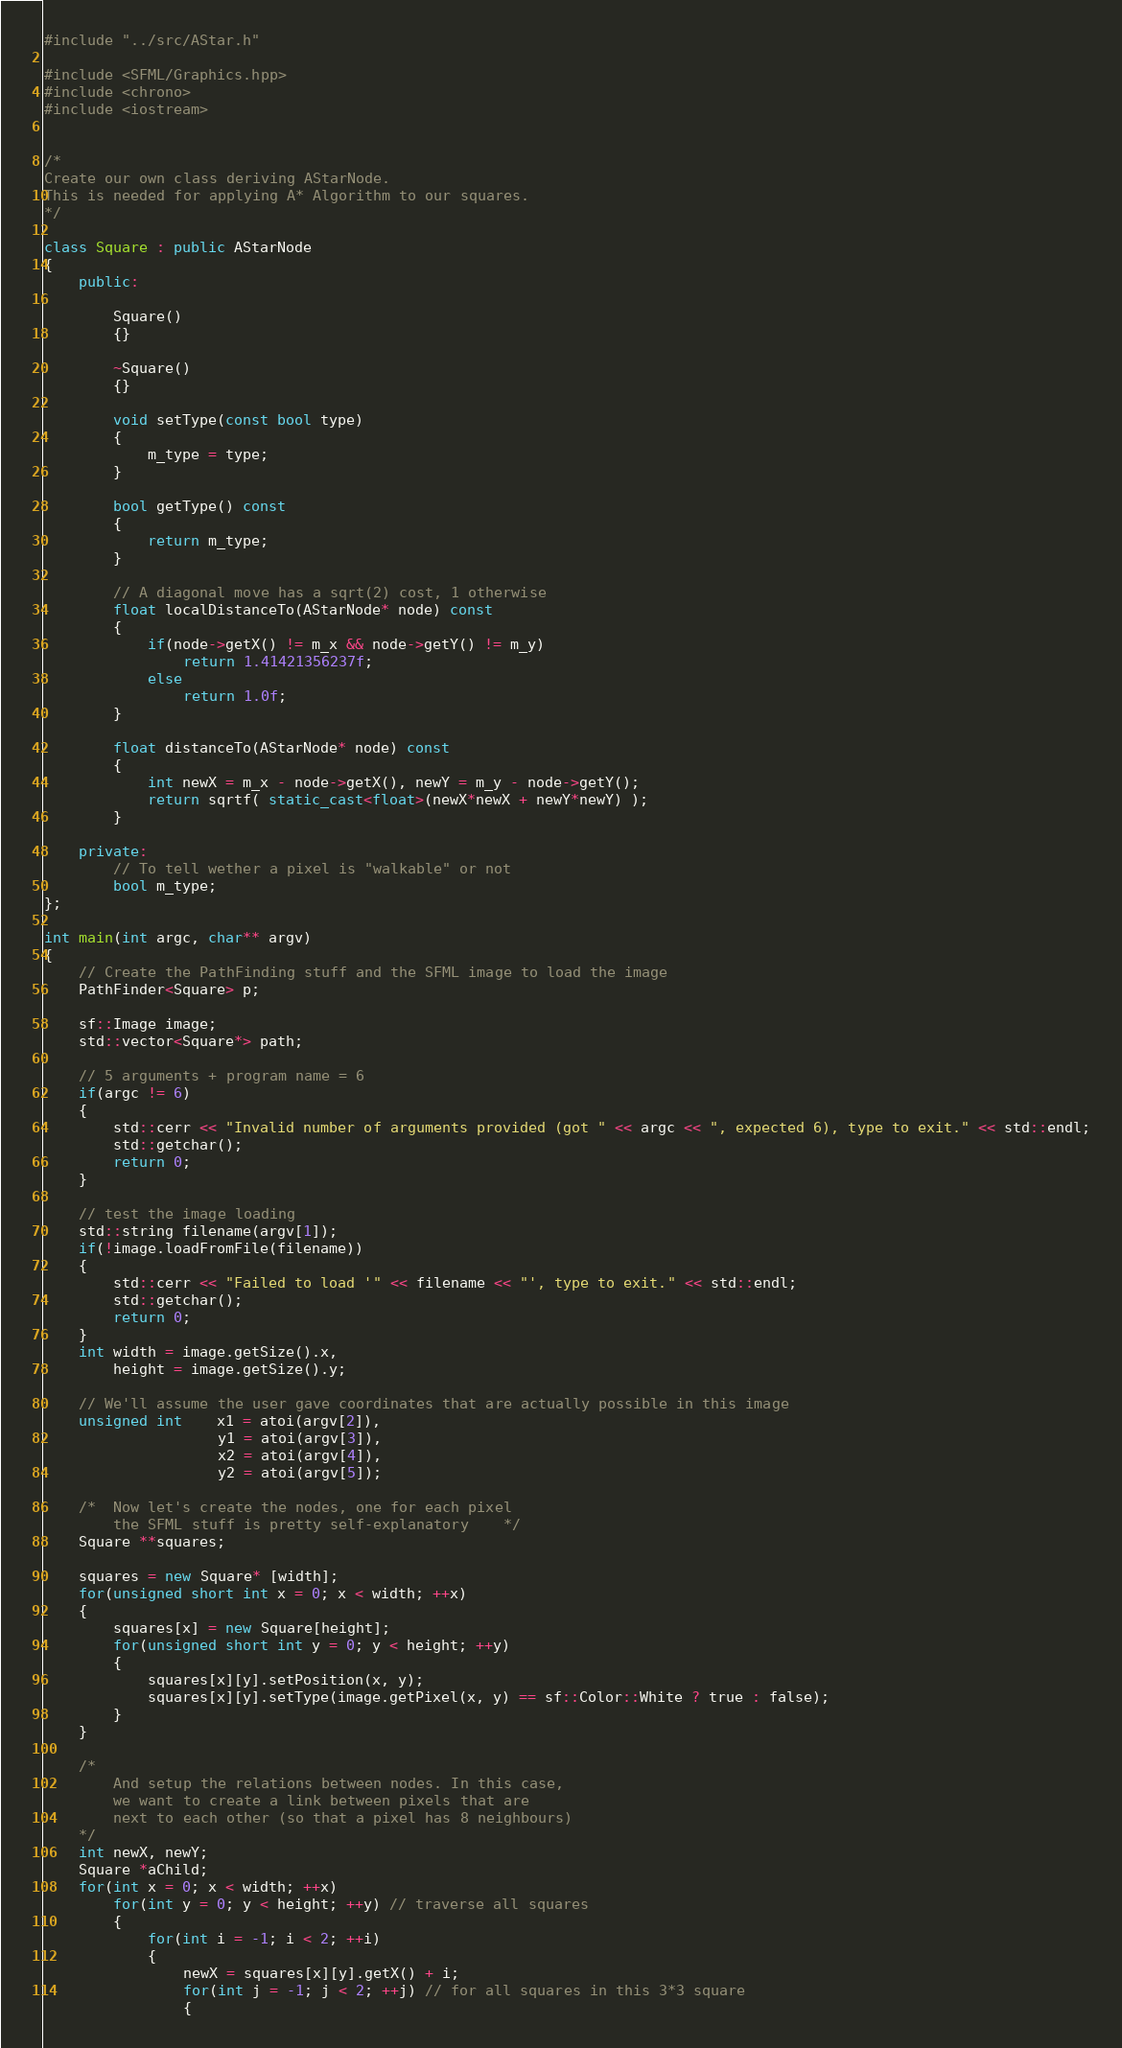Convert code to text. <code><loc_0><loc_0><loc_500><loc_500><_C++_>#include "../src/AStar.h"

#include <SFML/Graphics.hpp>
#include <chrono>
#include <iostream>


/*
Create our own class deriving AStarNode.
This is needed for applying A* Algorithm to our squares.
*/

class Square : public AStarNode
{
	public:

		Square()
		{}

		~Square()
		{}

		void setType(const bool type)
		{
			m_type = type;
		}

		bool getType() const
		{
			return m_type;
		}

		// A diagonal move has a sqrt(2) cost, 1 otherwise
		float localDistanceTo(AStarNode* node) const
		{
			if(node->getX() != m_x && node->getY() != m_y)
				return 1.41421356237f;
			else
				return 1.0f;
		}

		float distanceTo(AStarNode* node) const
		{
			int newX = m_x - node->getX(), newY = m_y - node->getY();
			return sqrtf( static_cast<float>(newX*newX + newY*newY) );
		}

	private:
		// To tell wether a pixel is "walkable" or not
		bool m_type;
};

int main(int argc, char** argv)
{
	// Create the PathFinding stuff and the SFML image to load the image
	PathFinder<Square> p;
	
	sf::Image image;
	std::vector<Square*> path;

	// 5 arguments + program name = 6
	if(argc != 6)
	{
		std::cerr << "Invalid number of arguments provided (got " << argc << ", expected 6), type to exit." << std::endl;
		std::getchar();
		return 0;
	}

	// test the image loading
	std::string filename(argv[1]);
	if(!image.loadFromFile(filename))
	{
		std::cerr << "Failed to load '" << filename << "', type to exit." << std::endl;
		std::getchar();
		return 0;
	}
	int width = image.getSize().x,
		height = image.getSize().y;

	// We'll assume the user gave coordinates that are actually possible in this image
	unsigned int	x1 = atoi(argv[2]),
					y1 = atoi(argv[3]),
					x2 = atoi(argv[4]),
					y2 = atoi(argv[5]);
	
	/* 	Now let's create the nodes, one for each pixel
		the SFML stuff is pretty self-explanatory	 */
	Square **squares;

	squares = new Square* [width];
	for(unsigned short int x = 0; x < width; ++x)
	{
		squares[x] = new Square[height];
		for(unsigned short int y = 0; y < height; ++y)
		{
			squares[x][y].setPosition(x, y);
			squares[x][y].setType(image.getPixel(x, y) == sf::Color::White ? true : false);
		}
	}

	/*
		And setup the relations between nodes. In this case,
		we want to create a link between pixels that are
		next to each other (so that a pixel has 8 neighbours)
	*/
	int newX, newY;
	Square *aChild;
	for(int x = 0; x < width; ++x)
		for(int y = 0; y < height; ++y) // traverse all squares
		{
			for(int i = -1; i < 2; ++i)
			{
				newX = squares[x][y].getX() + i;
				for(int j = -1; j < 2; ++j) // for all squares in this 3*3 square
				{</code> 